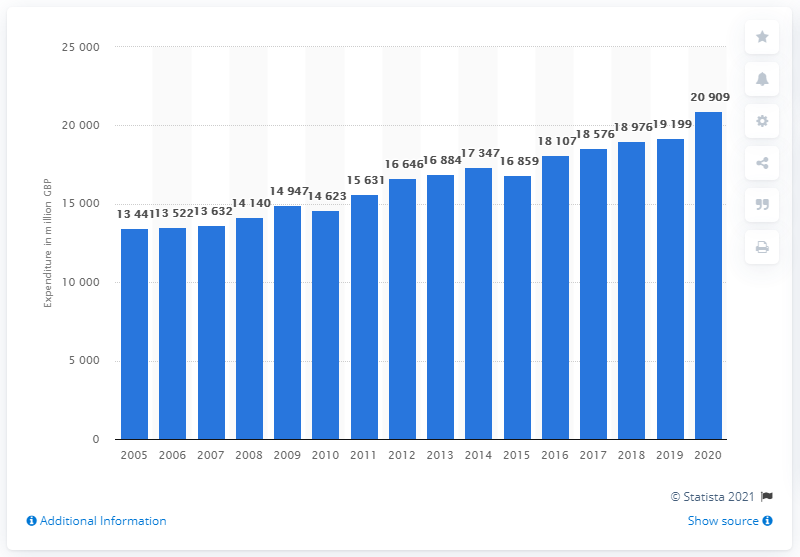Give some essential details in this illustration. The total consumer spending on meat in the UK in 2020 was 209,090. 